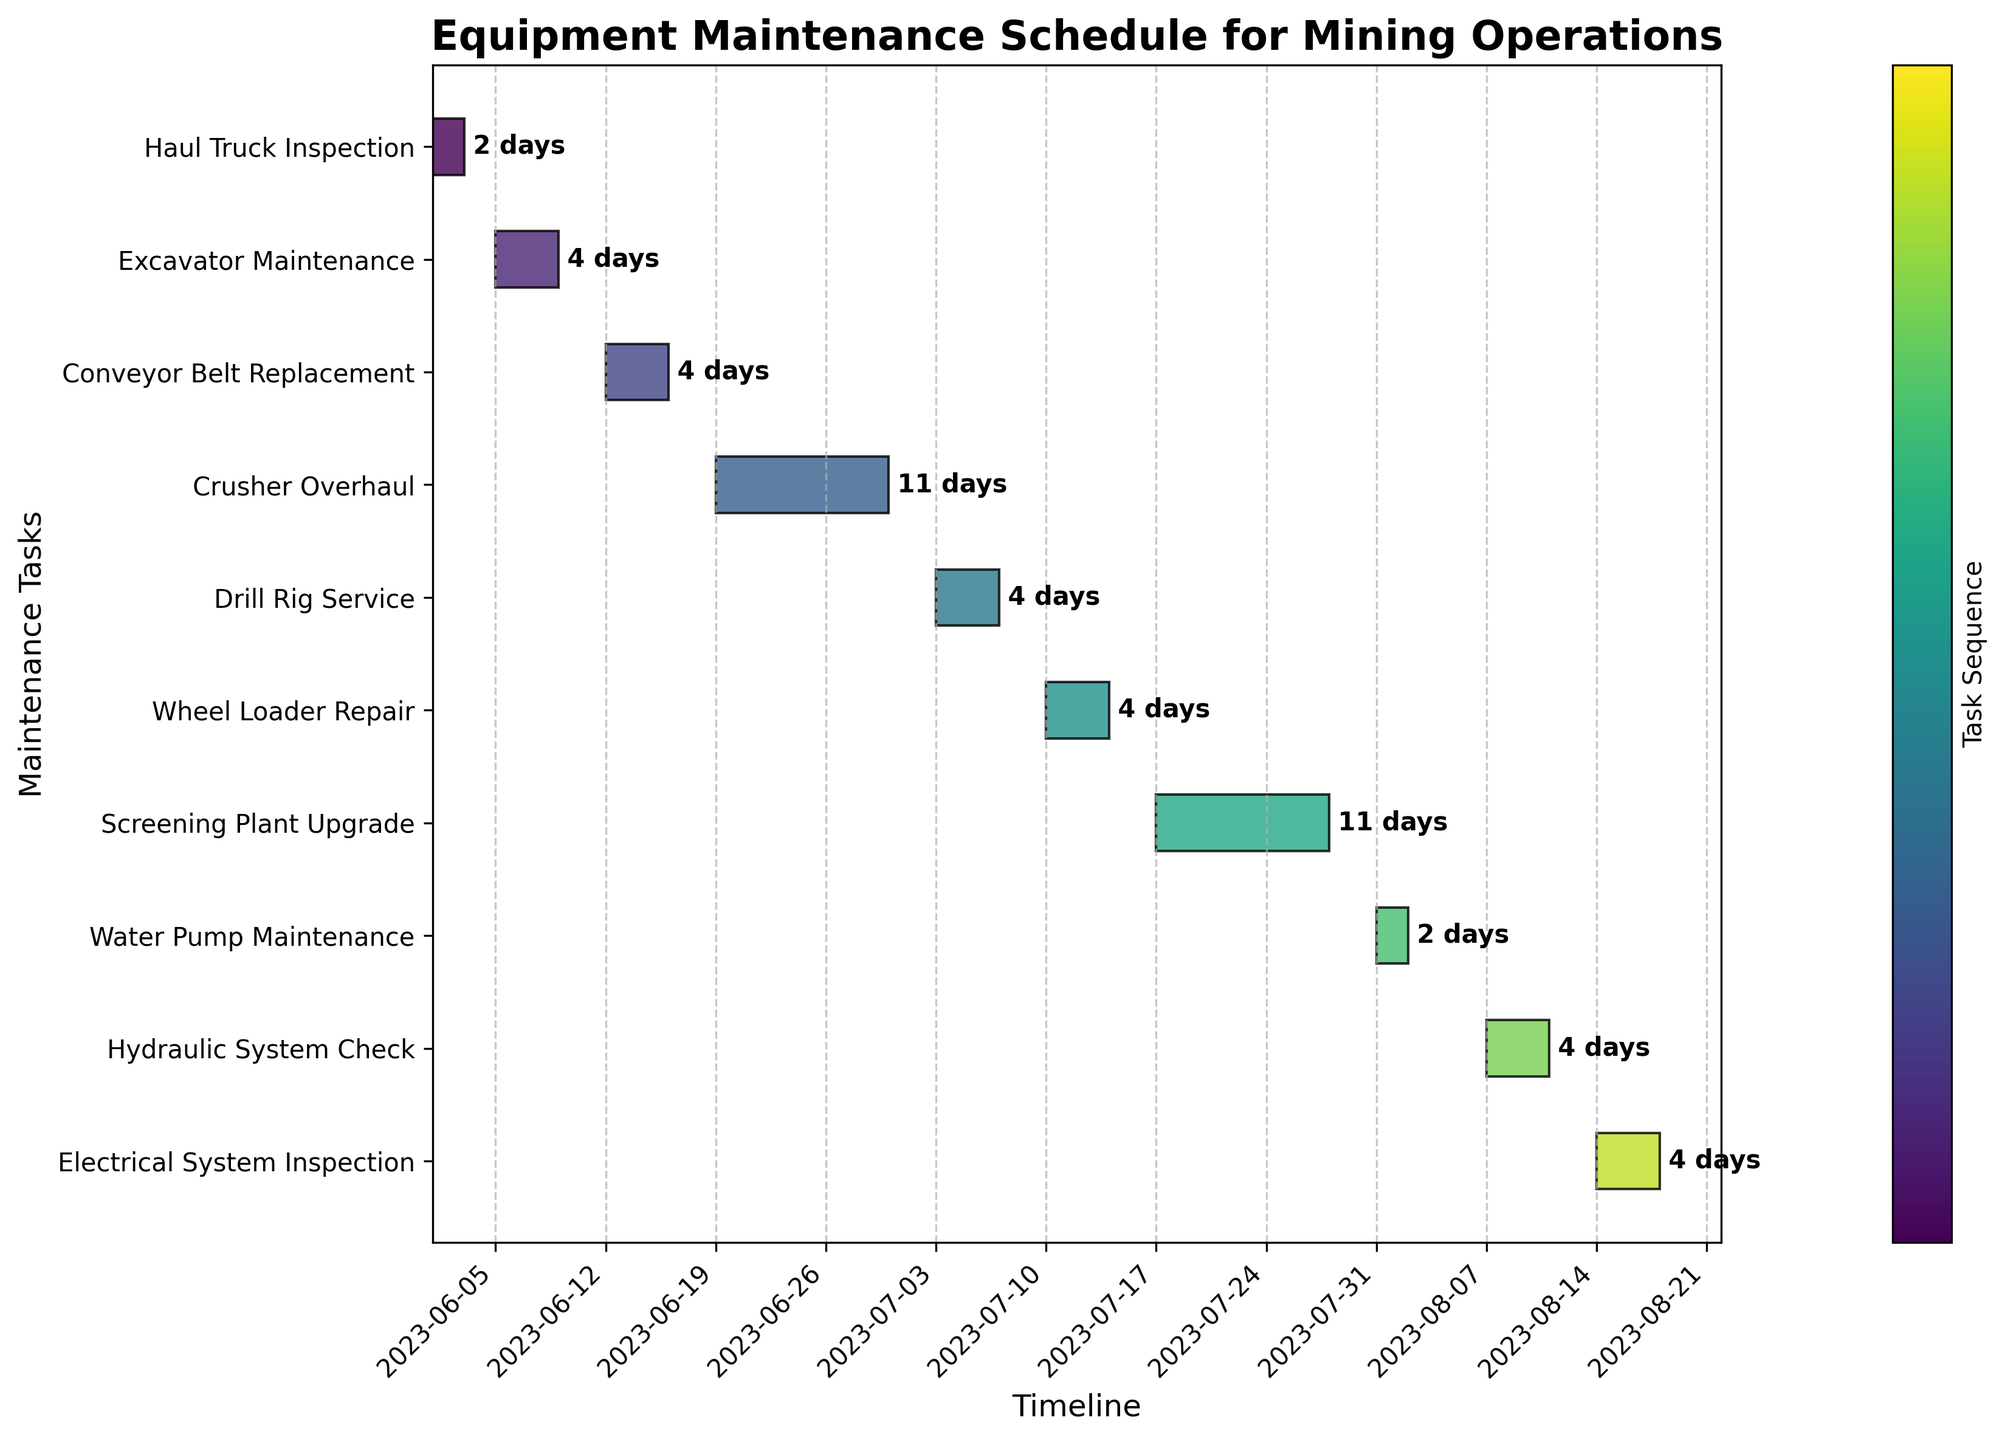What is the title of the chart? The title of the chart is displayed at the top and is written in bold. In this case, it can be read directly from the chart's title section.
Answer: Equipment Maintenance Schedule for Mining Operations How many days does the Haul Truck Inspection task last? To determine the duration, locate the Haul Truck Inspection task on the y-axis. The label next to its right endpoint on the horizontal bar indicates the duration.
Answer: 3 days Which maintenance task takes the longest duration? Compare the lengths of all the horizontal bars. The task with the longest bar has the longest duration. In this case, Crusher Overhaul and Screening Plant Upgrade both seem longer than others.
Answer: Crusher Overhaul and Screening Plant Upgrade When does the Conveyor Belt Replacement task start and end? Position yourself at the Conveyor Belt Replacement task on the y-axis and trace horizontally to find the start and end dates labeled at both ends of the bar.
Answer: Starts on 2023-06-12 and ends on 2023-06-16 How many maintenance tasks are scheduled to take place in July? Identify bars within the date range of July on the x-axis and count the number of tasks listed on the y-axis.
Answer: 4 tasks Which task comes directly after the Hydraulic System Check in August? Find the Hydraulic System Check task and identify the subsequent task on the y-axis that starts after it in August.
Answer: Electrical System Inspection What is the average duration of all maintenance tasks? Add up the durations of all tasks (3 + 5 + 5 + 12 + 5 + 5 + 12 + 3 + 5 + 5 = 60), then divide by the number of tasks (10).
Answer: 6 days Which maintenance tasks overlap in their schedule? Look for tasks with bars that overlap each other on the x-axis timeline. This requires careful examination across dates.
Answer: None overlap visibly How long does the Crusher Overhaul take from start to finish? Trace the Crusher Overhaul bar from its start date to its end date and read the labeled duration.
Answer: 12 days Which task is scheduled to start immediately after the Haul Truck Inspection ends? Locate the Haul Truck Inspection task on the y-axis, find its end date, and identify the task starting immediately after this date. Confirm by checking the start dates on the x-axis.
Answer: Excavator Maintenance 